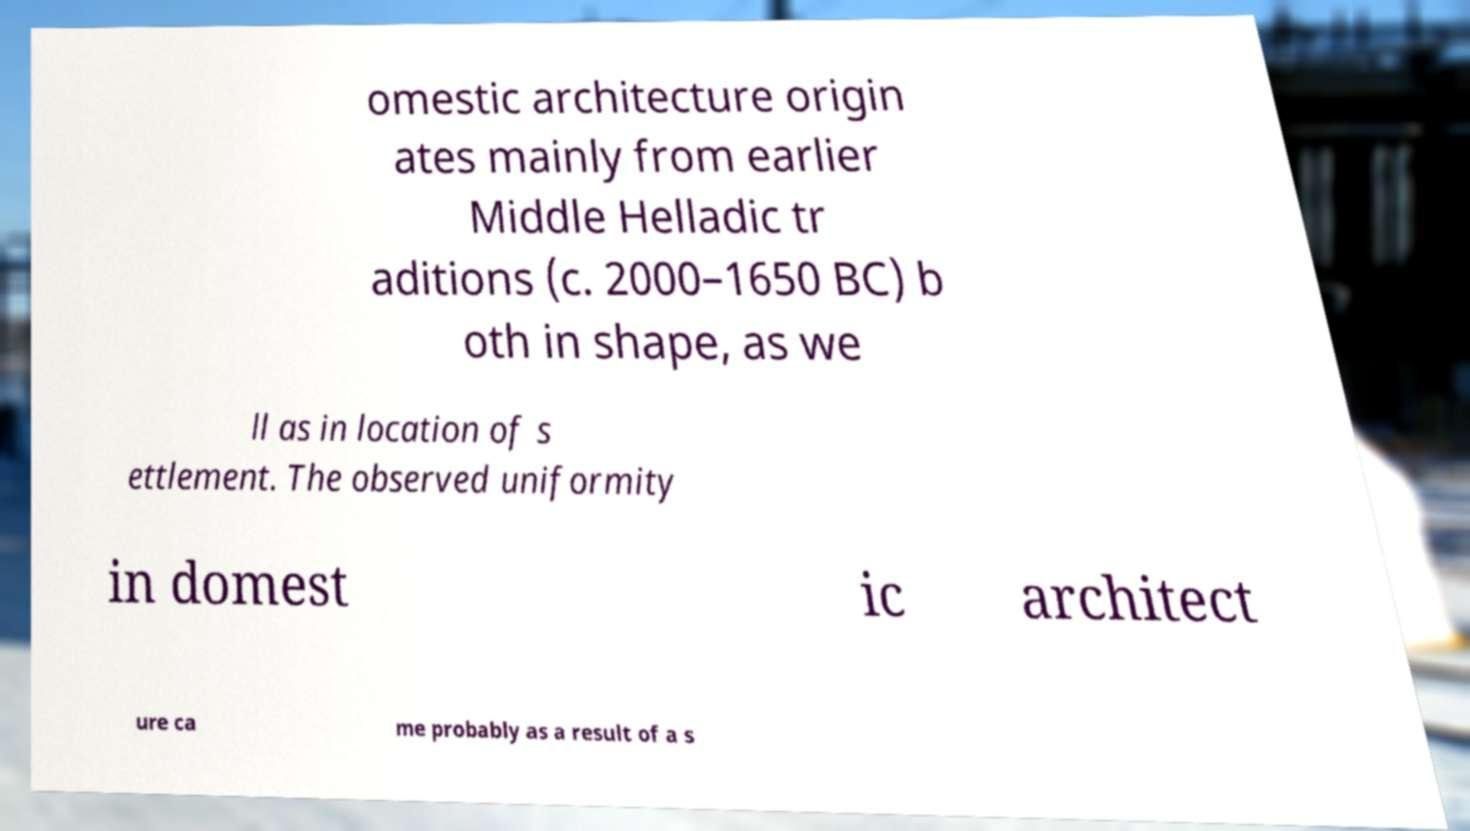Please read and relay the text visible in this image. What does it say? omestic architecture origin ates mainly from earlier Middle Helladic tr aditions (c. 2000–1650 BC) b oth in shape, as we ll as in location of s ettlement. The observed uniformity in domest ic architect ure ca me probably as a result of a s 